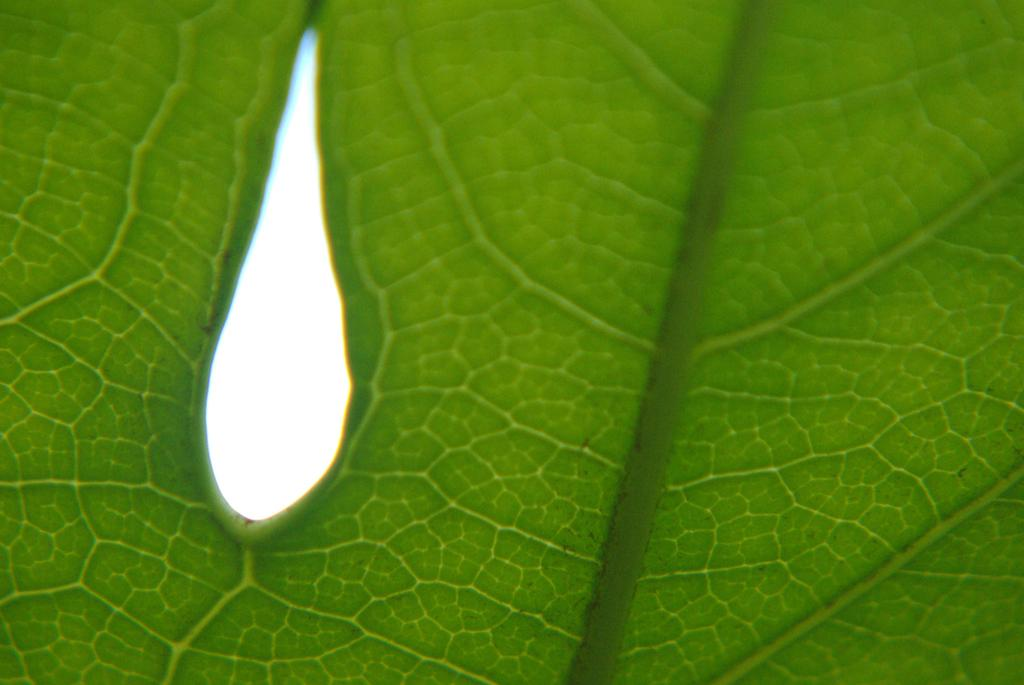What type of leaf can be seen in the image? There is a green color leaf in the image. How many maids are present in the image? There are no maids present in the image; it only features a green color leaf. What type of animal can be seen hopping on the floor in the image? There are no animals, such as frogs, present in the image; it only features a green color leaf. 